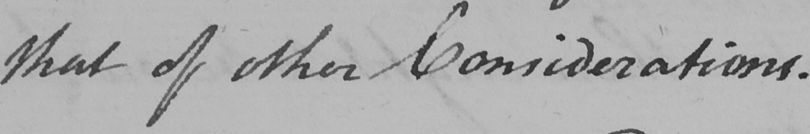Please provide the text content of this handwritten line. that of other considerations . 